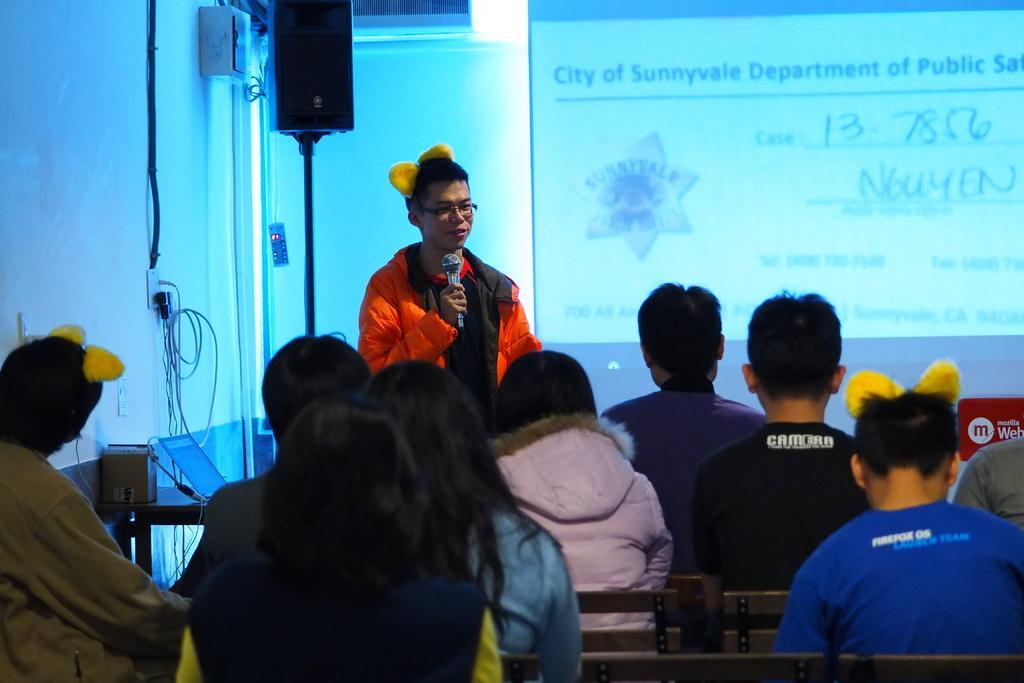In one or two sentences, can you explain what this image depicts? In the picture we can see group of people sitting on chairs, there is a person wearing orange color jacket standing, holding microphone in his hands and there is a laptop, in the background of the picture there is sound box, projector screen and there is a wall. 